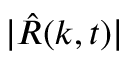<formula> <loc_0><loc_0><loc_500><loc_500>| \hat { R } ( k , t ) |</formula> 